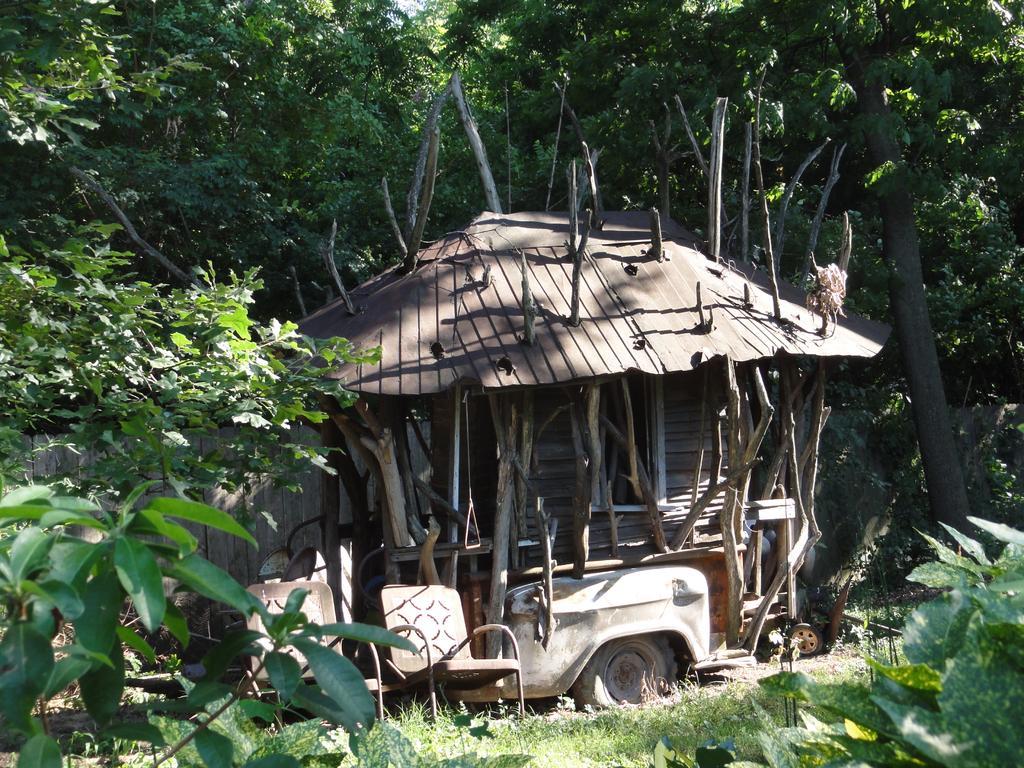Can you describe this image briefly? In this picture we can see chairs and a shed and in the background we can see trees. 